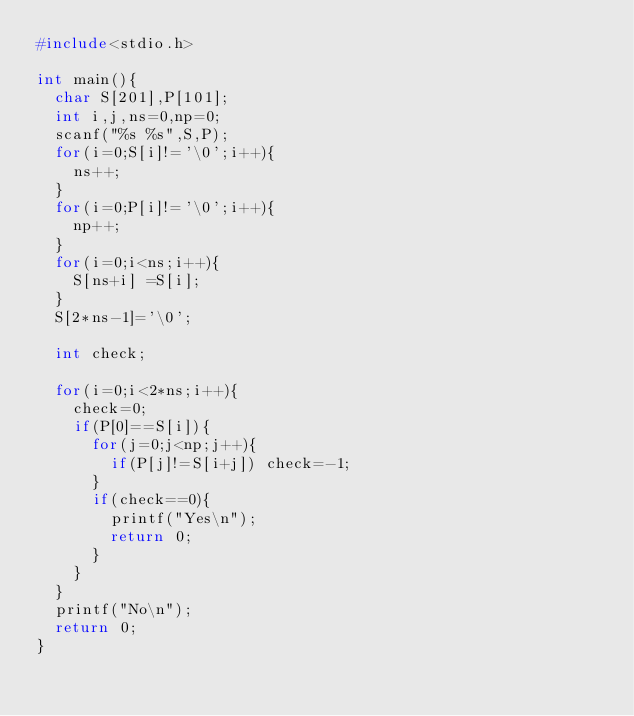Convert code to text. <code><loc_0><loc_0><loc_500><loc_500><_C_>#include<stdio.h>

int main(){
	char S[201],P[101];
	int i,j,ns=0,np=0;
	scanf("%s %s",S,P);
	for(i=0;S[i]!='\0';i++){
		ns++;
	}
	for(i=0;P[i]!='\0';i++){
		np++;
	}
	for(i=0;i<ns;i++){
		S[ns+i] =S[i];
	}
	S[2*ns-1]='\0';
	
	int check;
	
	for(i=0;i<2*ns;i++){
		check=0;
		if(P[0]==S[i]){
			for(j=0;j<np;j++){
				if(P[j]!=S[i+j]) check=-1;
			}
			if(check==0){
				printf("Yes\n");
				return 0;
			}
		}
	}
	printf("No\n");
	return 0;
}</code> 